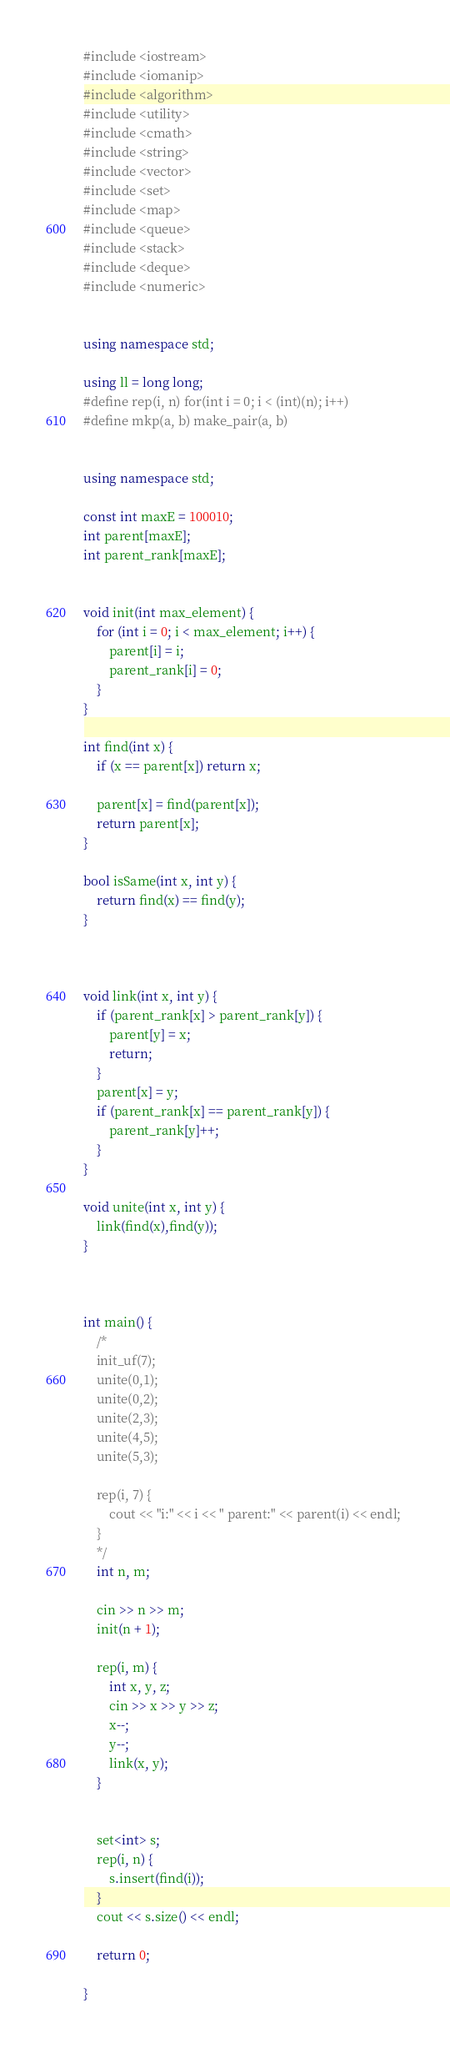<code> <loc_0><loc_0><loc_500><loc_500><_C++_>#include <iostream>
#include <iomanip>
#include <algorithm>
#include <utility>
#include <cmath>
#include <string>
#include <vector>
#include <set>
#include <map>
#include <queue>
#include <stack>
#include <deque>
#include <numeric>


using namespace std;

using ll = long long;
#define rep(i, n) for(int i = 0; i < (int)(n); i++)
#define mkp(a, b) make_pair(a, b)


using namespace std;

const int maxE = 100010;
int parent[maxE];
int parent_rank[maxE];


void init(int max_element) {
	for (int i = 0; i < max_element; i++) {
		parent[i] = i;
		parent_rank[i] = 0; 
	}
}

int find(int x) {
	if (x == parent[x]) return x;
	
	parent[x] = find(parent[x]);
	return parent[x];
}

bool isSame(int x, int y) {
	return find(x) == find(y);
}



void link(int x, int y) {
	if (parent_rank[x] > parent_rank[y]) {
		parent[y] = x;
		return;
	}
	parent[x] = y;
	if (parent_rank[x] == parent_rank[y]) {
		parent_rank[y]++;
	}
}

void unite(int x, int y) {
	link(find(x),find(y));
}



int main() {
	/*
	init_uf(7);
	unite(0,1);
	unite(0,2);
	unite(2,3);
	unite(4,5);
	unite(5,3);

	rep(i, 7) {
		cout << "i:" << i << " parent:" << parent(i) << endl; 
	}
	*/
	int n, m;

	cin >> n >> m;
	init(n + 1);

	rep(i, m) {
		int x, y, z;
		cin >> x >> y >> z;
		x--;
		y--;
		link(x, y);
	}


	set<int> s;
	rep(i, n) {
		s.insert(find(i));
	}
	cout << s.size() << endl;

	return 0;

}</code> 